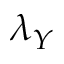<formula> <loc_0><loc_0><loc_500><loc_500>\lambda _ { Y }</formula> 